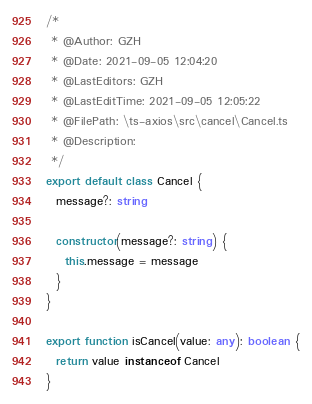<code> <loc_0><loc_0><loc_500><loc_500><_TypeScript_>/*
 * @Author: GZH
 * @Date: 2021-09-05 12:04:20
 * @LastEditors: GZH
 * @LastEditTime: 2021-09-05 12:05:22
 * @FilePath: \ts-axios\src\cancel\Cancel.ts
 * @Description:
 */
export default class Cancel {
  message?: string

  constructor(message?: string) {
    this.message = message
  }
}

export function isCancel(value: any): boolean {
  return value instanceof Cancel
}
</code> 